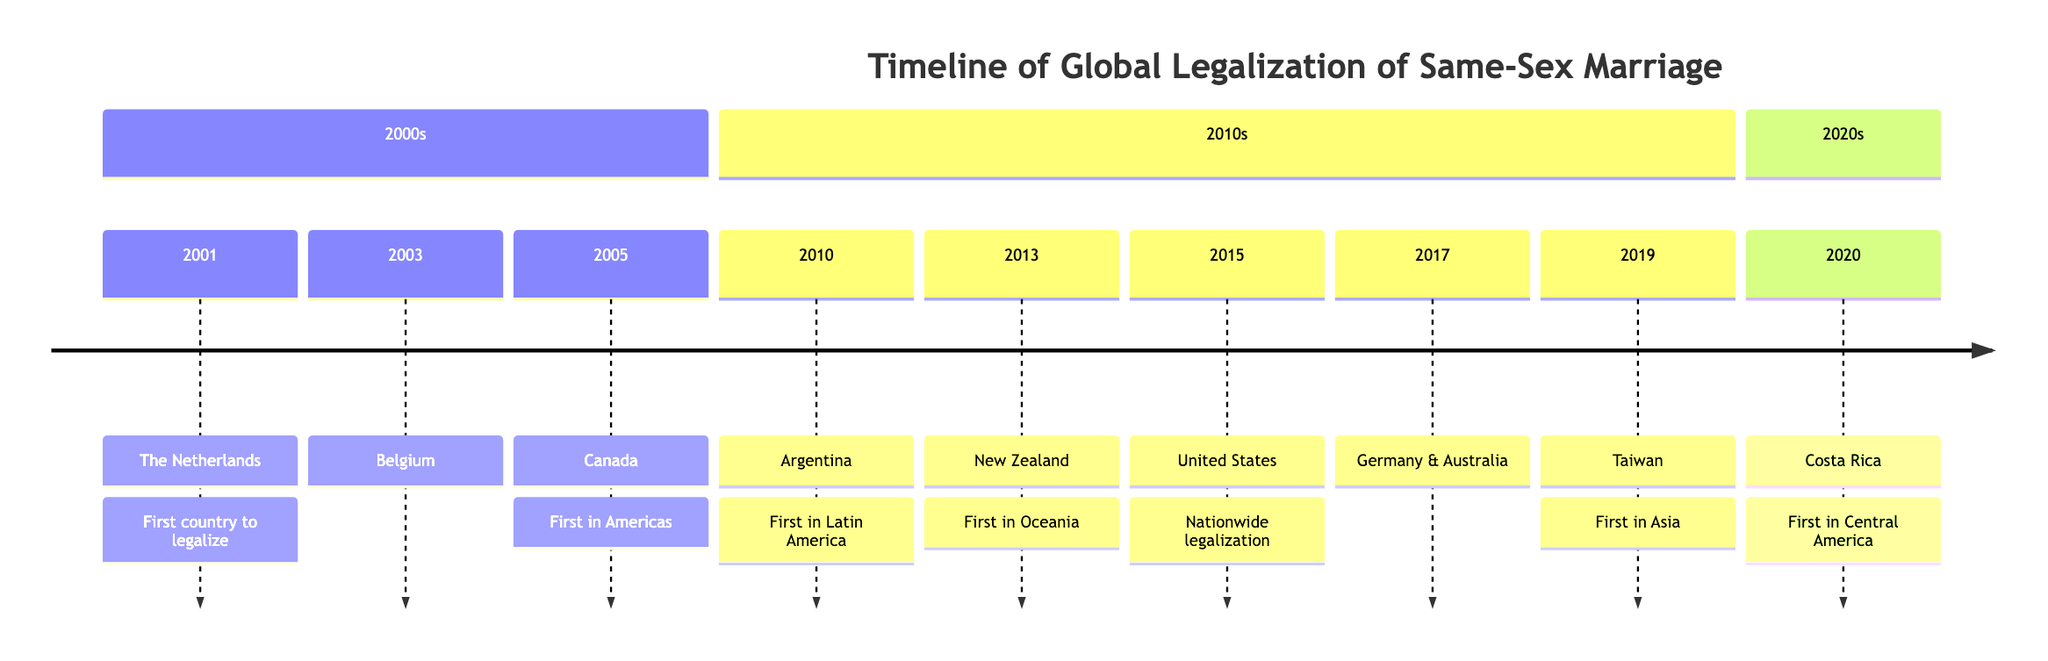What year did the Netherlands legalize same-sex marriage? The diagram states that the Netherlands legalized same-sex marriage in 2001.
Answer: 2001 Which country was the first in Latin America to legalize same-sex marriage? Referring to the diagram, Argentina is identified as the first country in Latin America to legalize same-sex marriage in 2010.
Answer: Argentina How many countries legalized same-sex marriage in 2017? According to the diagram, both Germany and Australia legalized same-sex marriage in 2017, which totals to two countries.
Answer: 2 What significant event happened on June 26, 2015, in the United States? The diagram indicates that on June 26, 2015, the U.S. Supreme Court's decision legalized same-sex marriage nationwide in the United States.
Answer: Nationwide legalization What region did Taiwan become a pioneer for in 2019? The diagram specifies that Taiwan was the first country in Asia to legalize same-sex marriage in 2019, thus making it a pioneer for the Asian region.
Answer: Asia Which country was the first to legalize same-sex marriage in Europe? The timeline shows that the Netherlands was the first country to legalize same-sex marriage in Europe in 2001.
Answer: Netherlands In which year did Costa Rica legalize same-sex marriage? The timeline clearly states that Costa Rica legalized same-sex marriage in the year 2020.
Answer: 2020 Which continent saw its first same-sex marriage legalization with Canada? Referring to the timeline, Canada was the first country in the Americas to legalize same-sex marriage in 2005.
Answer: Americas Which two countries legalized same-sex marriage simultaneously in 2017? The diagram indicates that both Germany and Australia legalized same-sex marriage in the same year of 2017.
Answer: Germany & Australia 